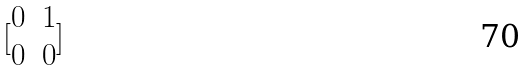Convert formula to latex. <formula><loc_0><loc_0><loc_500><loc_500>[ \begin{matrix} 0 & 1 \\ 0 & 0 \end{matrix} ]</formula> 